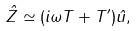<formula> <loc_0><loc_0><loc_500><loc_500>\hat { Z } \simeq ( i \omega T + T ^ { \prime } ) \hat { u } ,</formula> 